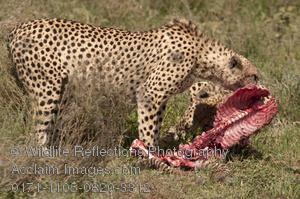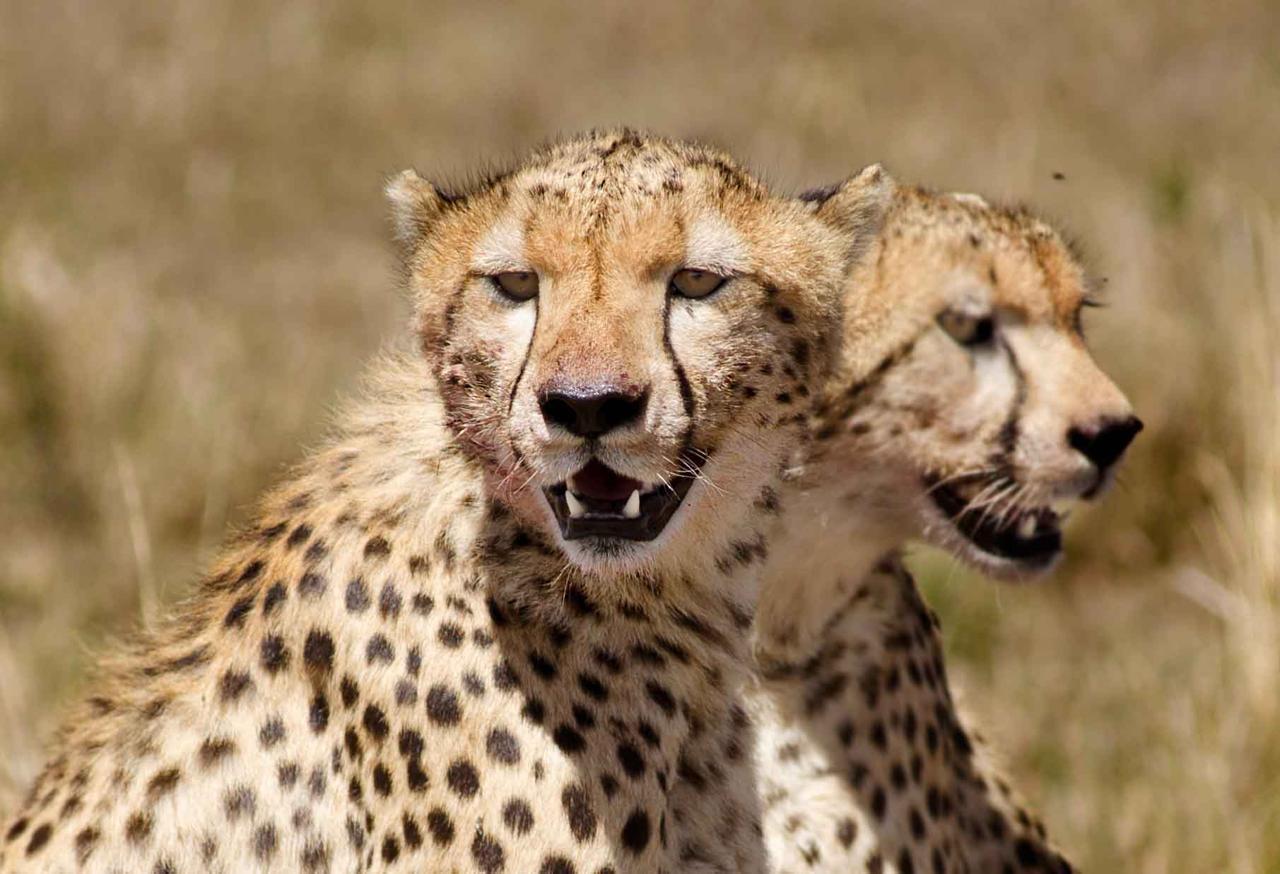The first image is the image on the left, the second image is the image on the right. Analyze the images presented: Is the assertion "An image shows two same-sized similarly-posed spotted cats with their heads close together." valid? Answer yes or no. Yes. 